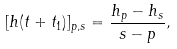Convert formula to latex. <formula><loc_0><loc_0><loc_500><loc_500>[ h ( t + t _ { 1 } ) ] _ { p , s } = \frac { h _ { p } - h _ { s } } { s - p } ,</formula> 